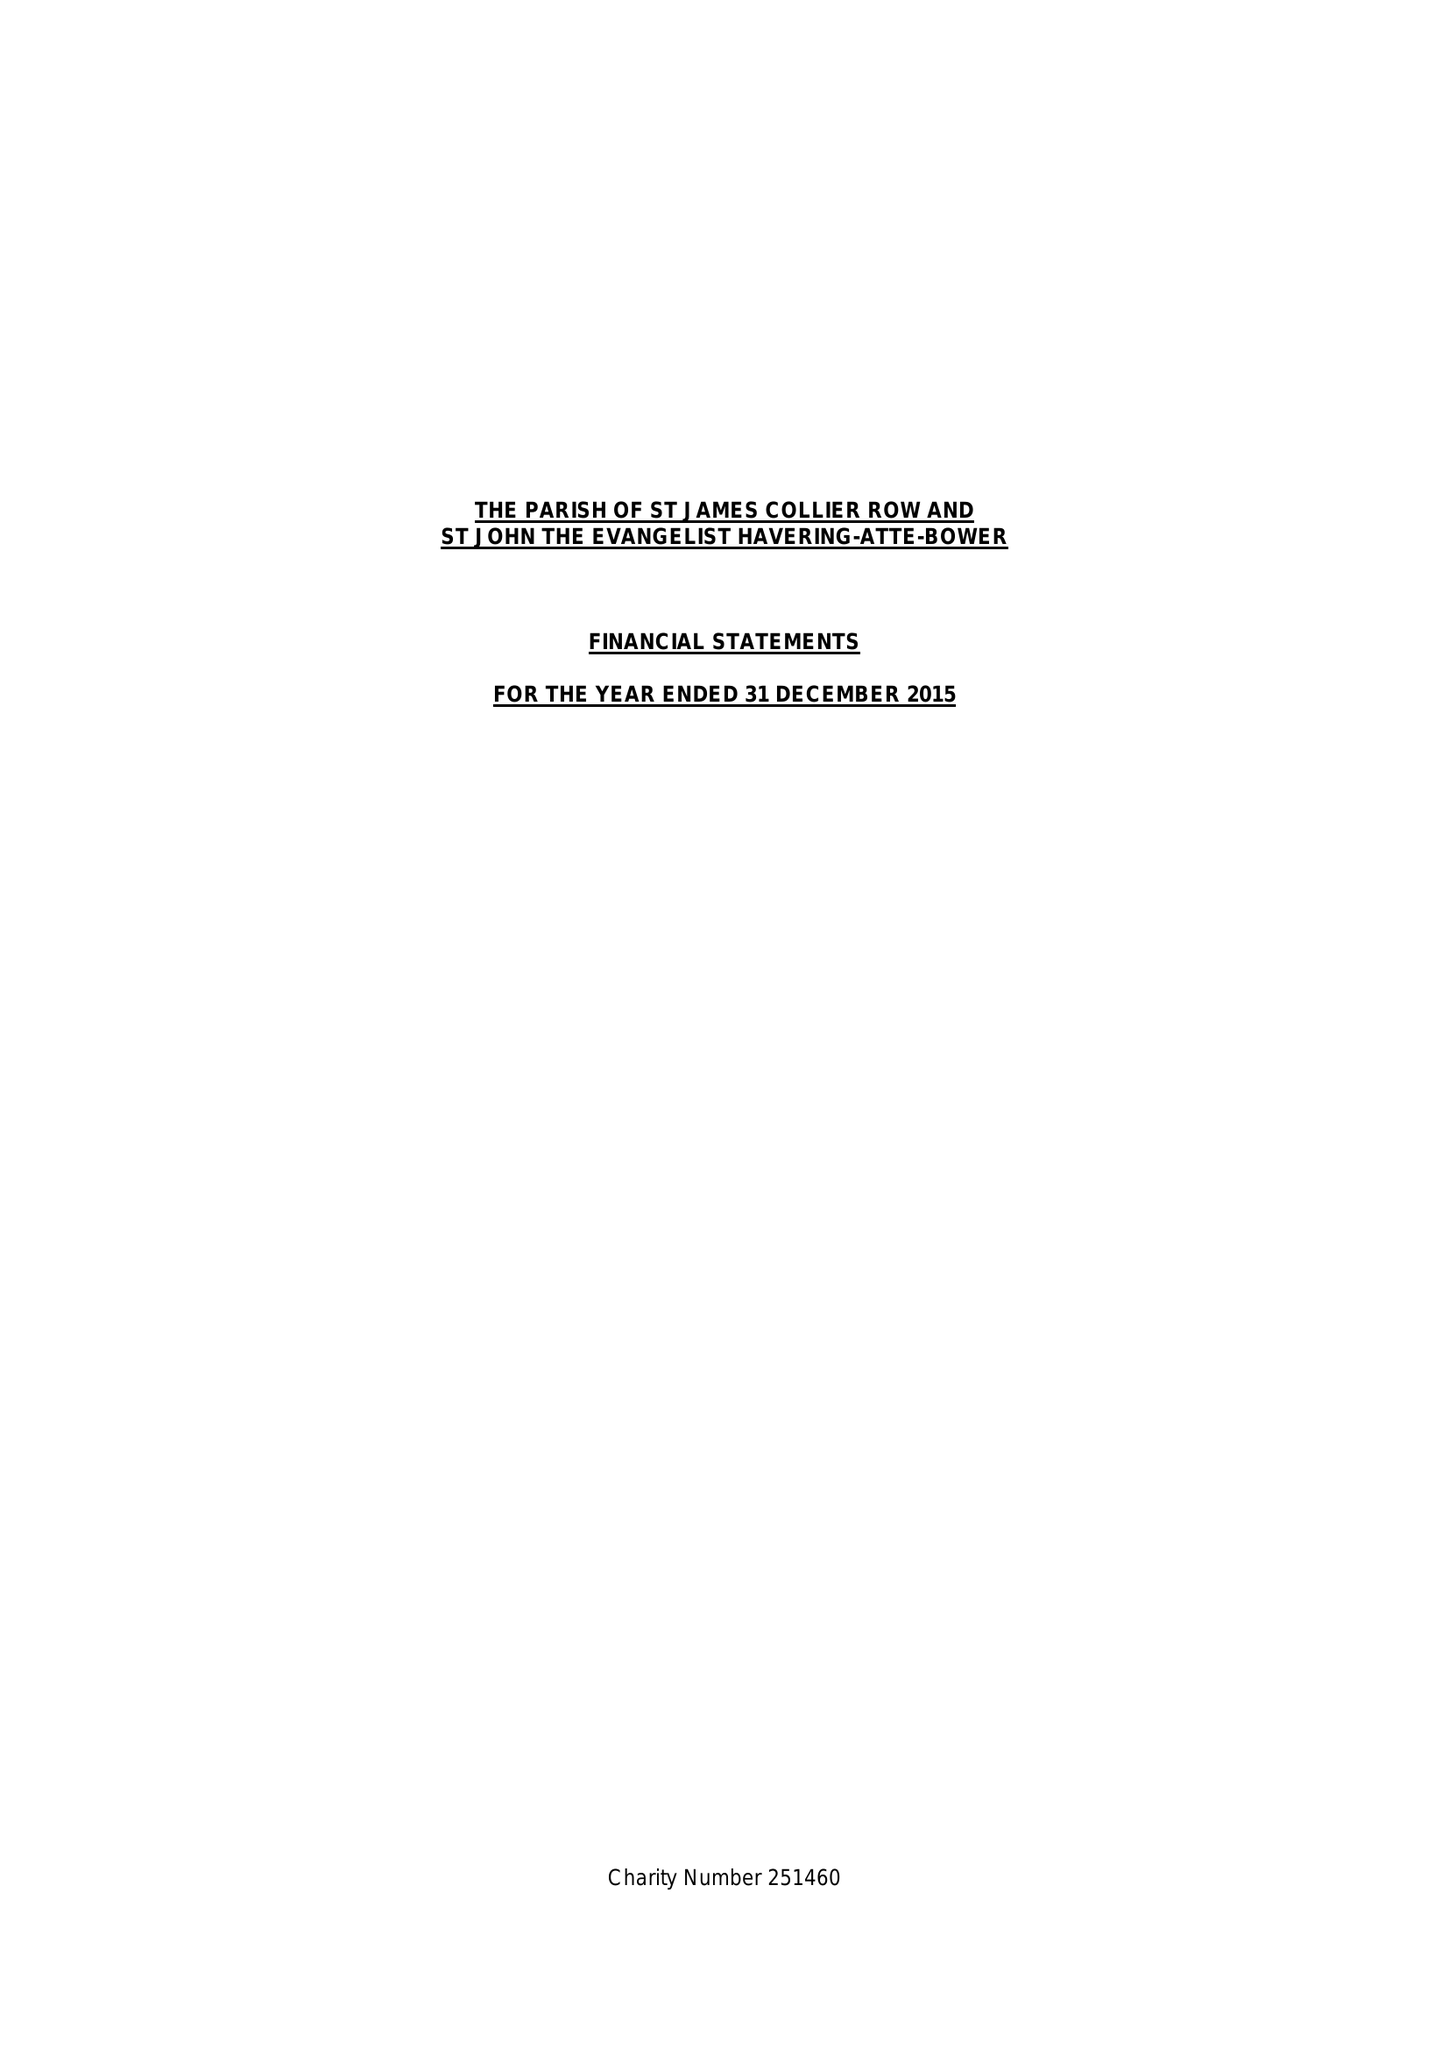What is the value for the charity_number?
Answer the question using a single word or phrase. 251460 